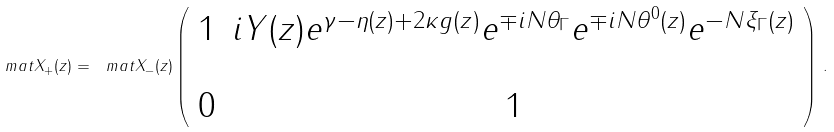Convert formula to latex. <formula><loc_0><loc_0><loc_500><loc_500>\ m a t { X } _ { + } ( z ) = \ m a t { X } _ { - } ( z ) \left ( \begin{array} { c c } 1 & i Y ( z ) e ^ { \gamma - \eta ( z ) + 2 \kappa g ( z ) } e ^ { \mp i N \theta _ { \Gamma } } e ^ { \mp i N \theta ^ { 0 } ( z ) } e ^ { - N \xi _ { \Gamma } ( z ) } \\ \\ 0 & 1 \end{array} \right ) \, .</formula> 